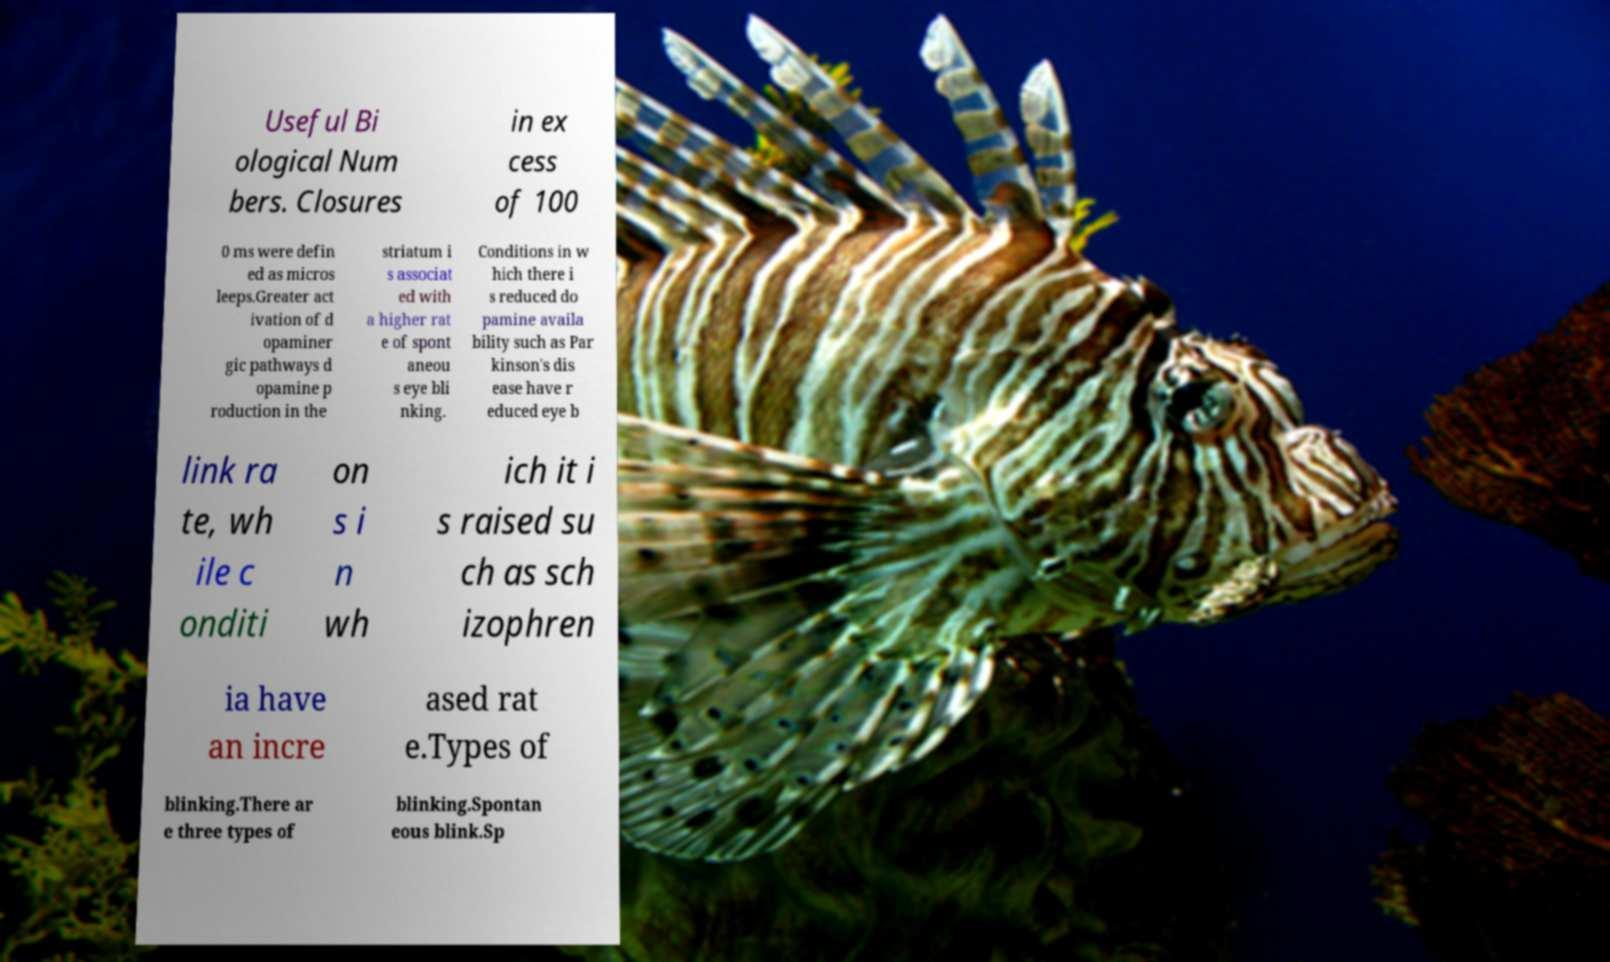For documentation purposes, I need the text within this image transcribed. Could you provide that? Useful Bi ological Num bers. Closures in ex cess of 100 0 ms were defin ed as micros leeps.Greater act ivation of d opaminer gic pathways d opamine p roduction in the striatum i s associat ed with a higher rat e of spont aneou s eye bli nking. Conditions in w hich there i s reduced do pamine availa bility such as Par kinson's dis ease have r educed eye b link ra te, wh ile c onditi on s i n wh ich it i s raised su ch as sch izophren ia have an incre ased rat e.Types of blinking.There ar e three types of blinking.Spontan eous blink.Sp 